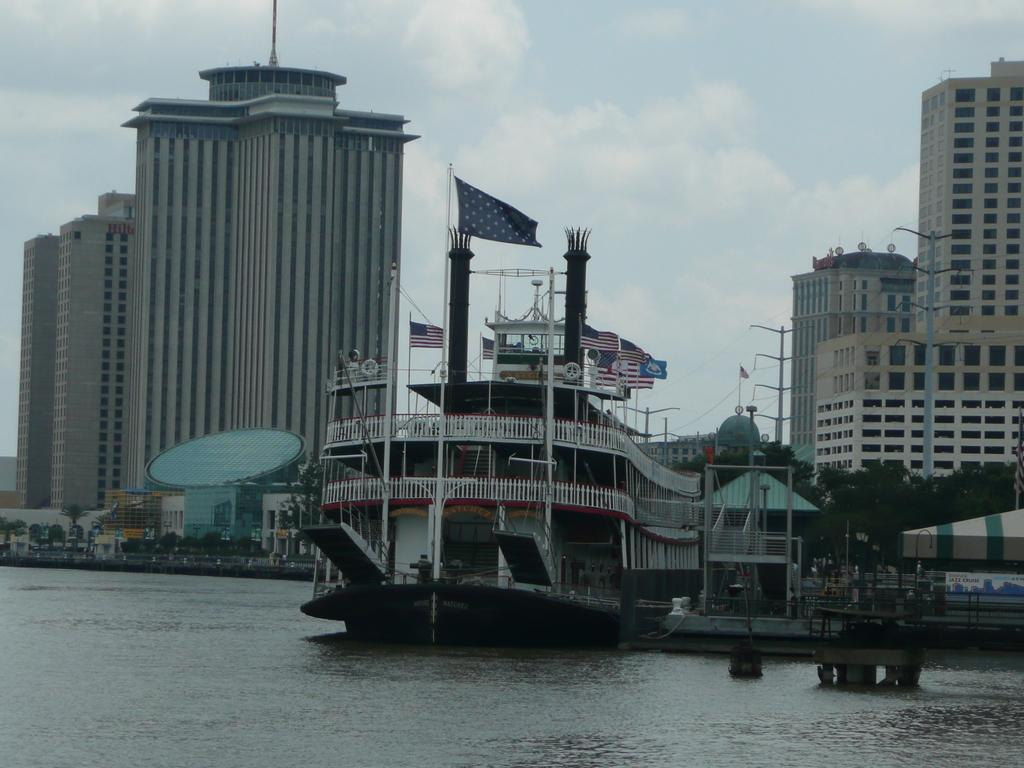What is the main subject in the middle of the image? There is a ship in the middle of the image. What is the ship's location in relation to the water? The ship is on the water. What can be seen in the background of the image? There are flags, buildings, poles, trees, and clouds visible in the background of the image. What type of stocking is being worn by the group of people in the hospital in the image? There are no people or hospitals present in the image; it features a ship on the water with flags and various background elements. 